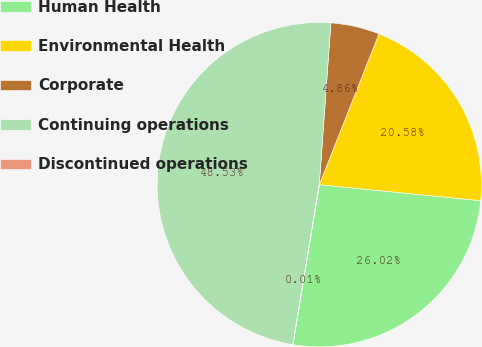Convert chart. <chart><loc_0><loc_0><loc_500><loc_500><pie_chart><fcel>Human Health<fcel>Environmental Health<fcel>Corporate<fcel>Continuing operations<fcel>Discontinued operations<nl><fcel>26.02%<fcel>20.58%<fcel>4.86%<fcel>48.53%<fcel>0.01%<nl></chart> 